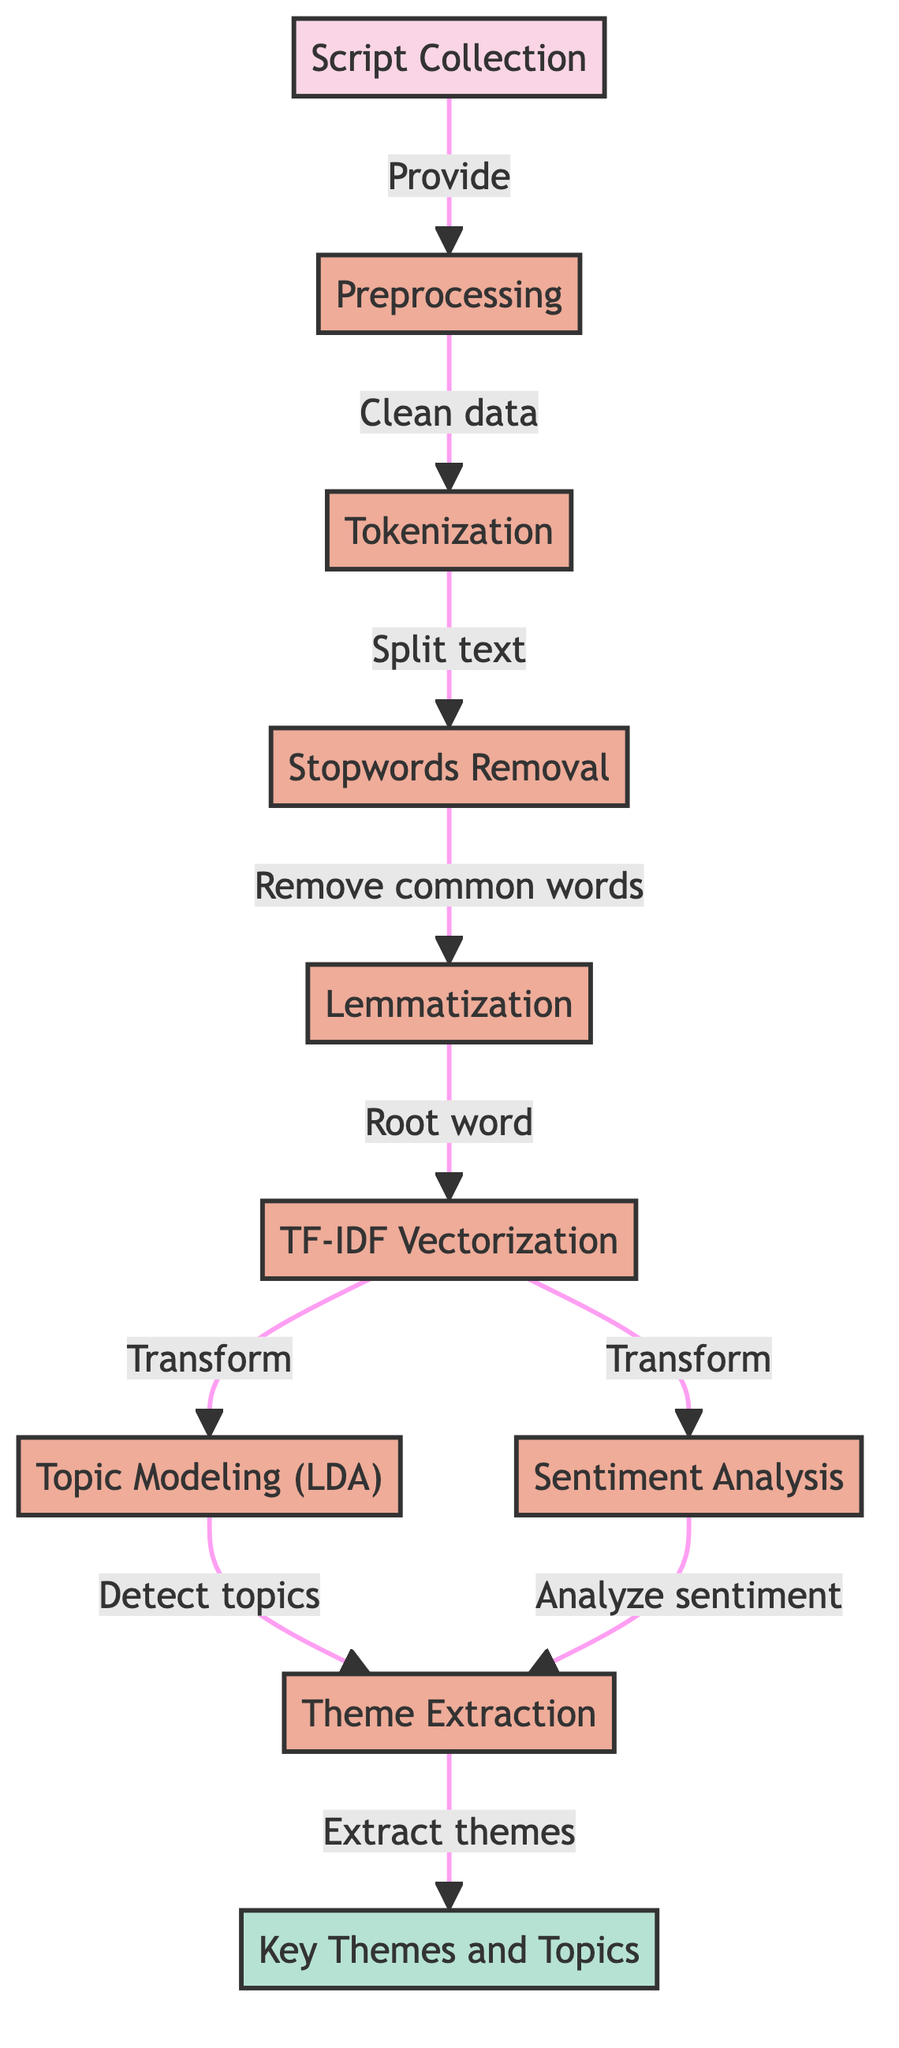What is the first step in the process? The first step in the process is labeled as "Script Collection," which is indicated as the starting point of the flowchart.
Answer: Script Collection How many processes are there in the diagram? By counting the nodes with the class "process," we can see there are a total of 8 processes.
Answer: 8 What does the "TF-IDF Vectorization" node transform data into? The "TF-IDF Vectorization" node transforms the data into numerical representations of text based on the frequency of terms, leading to two branches for analysis.
Answer: Transform Which two analyses follow the "TF-IDF Vectorization"? The two analyses that follow are "Topic Modeling (LDA)" and "Sentiment Analysis," as shown by the branching paths.
Answer: Topic Modeling (LDA) and Sentiment Analysis What is the final output of the diagram? The final output node named "Key Themes and Topics" summarizes the results of the previous analyses, representing the end goal of the process.
Answer: Key Themes and Topics Which step directly follows "Stopwords Removal"? The step that directly follows "Stopwords Removal" is "Lemmatization," indicating the next action in the data processing sequence.
Answer: Lemmatization What is the main purpose of "Sentiment Analysis" in this diagram? The main purpose of "Sentiment Analysis" is to analyze the emotional tone of the dialogues extracted from the scripts, which is indicated by its position in the flow.
Answer: Analyze sentiment How do "Theme Extraction" and "Key Themes and Topics" relate? "Theme Extraction" feeds directly into "Key Themes and Topics," indicating that the themes identified will help determine the final topics represented.
Answer: Extract themes What will be removed in the "Stopwords Removal" step? "Stopwords Removal" will remove common words from the text that are not useful for theme detection, such as "and," "the," and "is."
Answer: Remove common words 